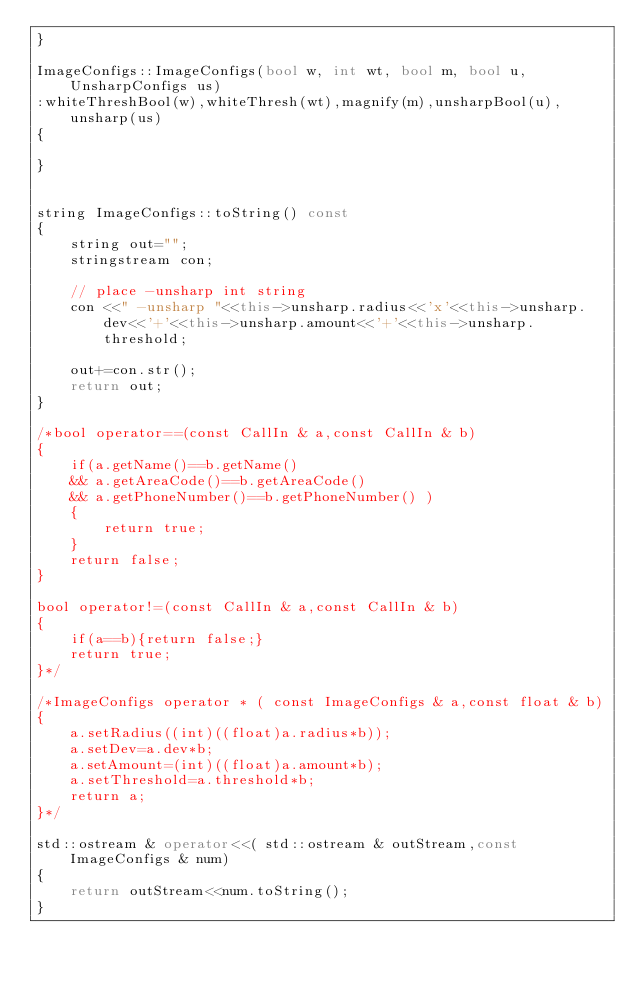Convert code to text. <code><loc_0><loc_0><loc_500><loc_500><_C++_>}

ImageConfigs::ImageConfigs(bool w, int wt, bool m, bool u, UnsharpConfigs us)
:whiteThreshBool(w),whiteThresh(wt),magnify(m),unsharpBool(u),unsharp(us)
{
	
}


string ImageConfigs::toString() const
{
	string out="";
	stringstream con;
	
	// place -unsharp int string
	con <<" -unsharp "<<this->unsharp.radius<<'x'<<this->unsharp.dev<<'+'<<this->unsharp.amount<<'+'<<this->unsharp.threshold;
		
	out+=con.str();
	return out;
}

/*bool operator==(const CallIn & a,const CallIn & b)
{
	if(a.getName()==b.getName() 
	&& a.getAreaCode()==b.getAreaCode() 
	&& a.getPhoneNumber()==b.getPhoneNumber() )
	{
		return true;
	}
	return false;
}

bool operator!=(const CallIn & a,const CallIn & b)
{
	if(a==b){return false;}
	return true;
}*/

/*ImageConfigs operator * ( const ImageConfigs & a,const float & b)
{
	a.setRadius((int)((float)a.radius*b));
	a.setDev=a.dev*b;
	a.setAmount=(int)((float)a.amount*b);
	a.setThreshold=a.threshold*b;
	return a;
}*/

std::ostream & operator<<( std::ostream & outStream,const ImageConfigs & num)
{
	return outStream<<num.toString();
}

</code> 